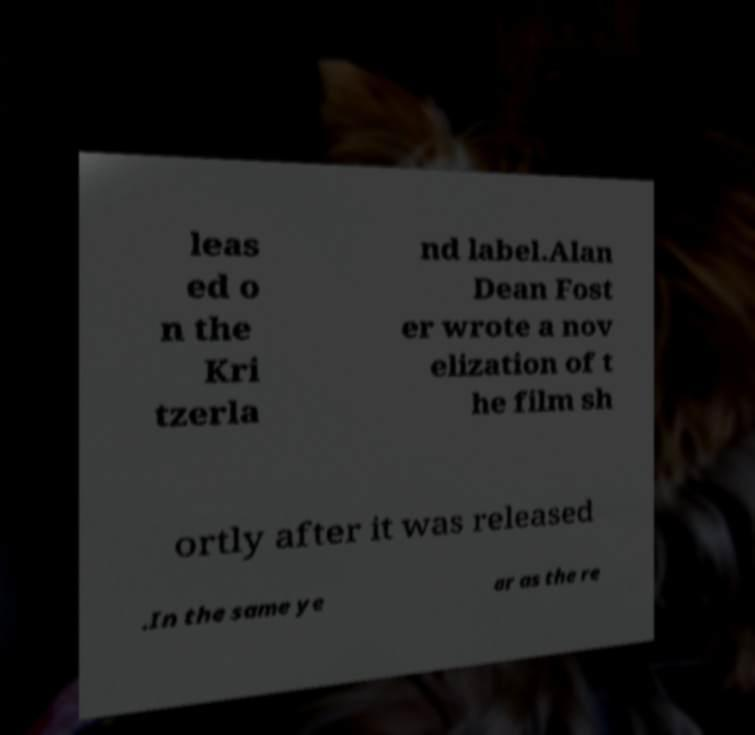Please identify and transcribe the text found in this image. leas ed o n the Kri tzerla nd label.Alan Dean Fost er wrote a nov elization of t he film sh ortly after it was released .In the same ye ar as the re 